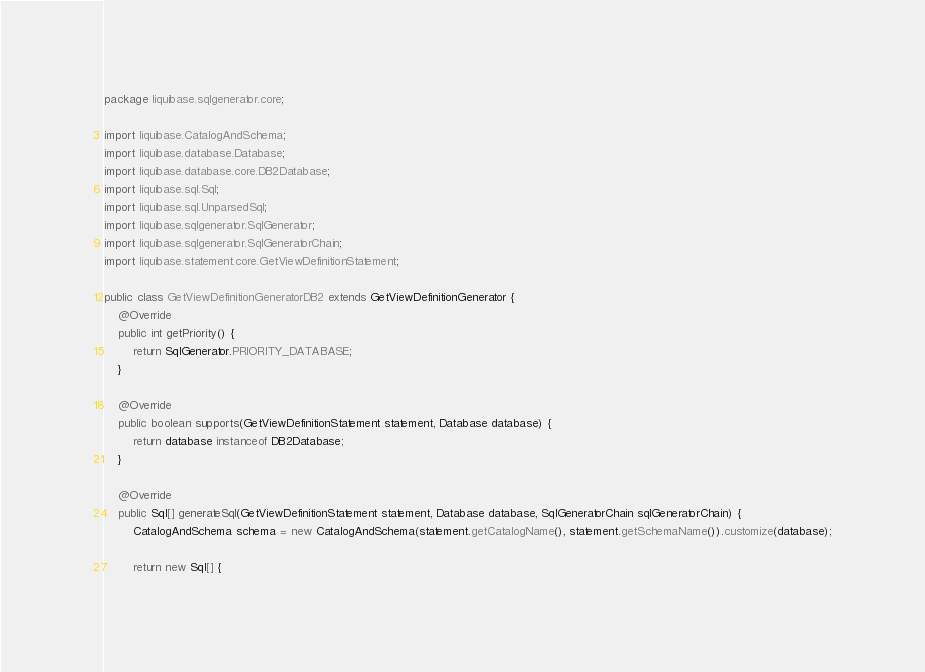Convert code to text. <code><loc_0><loc_0><loc_500><loc_500><_Java_>package liquibase.sqlgenerator.core;

import liquibase.CatalogAndSchema;
import liquibase.database.Database;
import liquibase.database.core.DB2Database;
import liquibase.sql.Sql;
import liquibase.sql.UnparsedSql;
import liquibase.sqlgenerator.SqlGenerator;
import liquibase.sqlgenerator.SqlGeneratorChain;
import liquibase.statement.core.GetViewDefinitionStatement;

public class GetViewDefinitionGeneratorDB2 extends GetViewDefinitionGenerator {
    @Override
    public int getPriority() {
        return SqlGenerator.PRIORITY_DATABASE;
    }

    @Override
    public boolean supports(GetViewDefinitionStatement statement, Database database) {
        return database instanceof DB2Database;
    }

    @Override
    public Sql[] generateSql(GetViewDefinitionStatement statement, Database database, SqlGeneratorChain sqlGeneratorChain) {
        CatalogAndSchema schema = new CatalogAndSchema(statement.getCatalogName(), statement.getSchemaName()).customize(database);

        return new Sql[] {</code> 